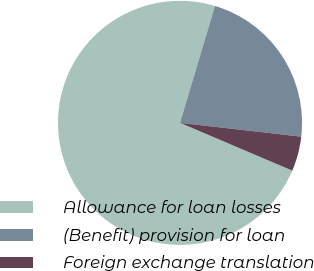Convert chart to OTSL. <chart><loc_0><loc_0><loc_500><loc_500><pie_chart><fcel>Allowance for loan losses<fcel>(Benefit) provision for loan<fcel>Foreign exchange translation<nl><fcel>73.22%<fcel>22.18%<fcel>4.6%<nl></chart> 